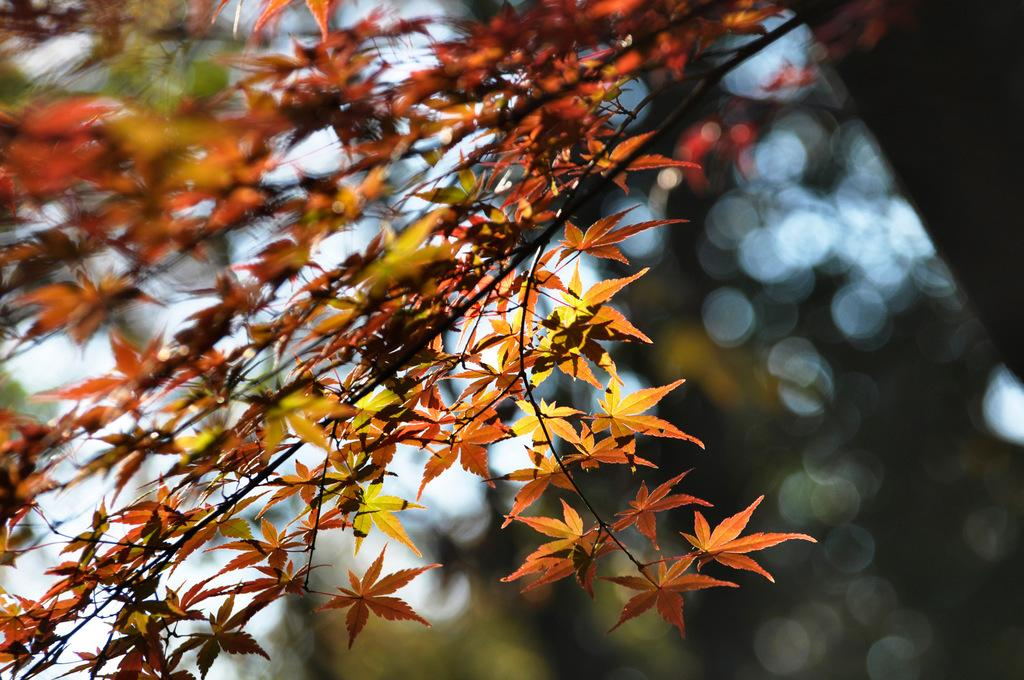What is the main subject of the image? The main subject of the image is a branch of a tree. Can you describe the branch in more detail? The branch has some leaves on it. What type of toothpaste is being used to clean the leaves on the branch? There is no toothpaste present in the image, and the leaves on the branch are not being cleaned. 